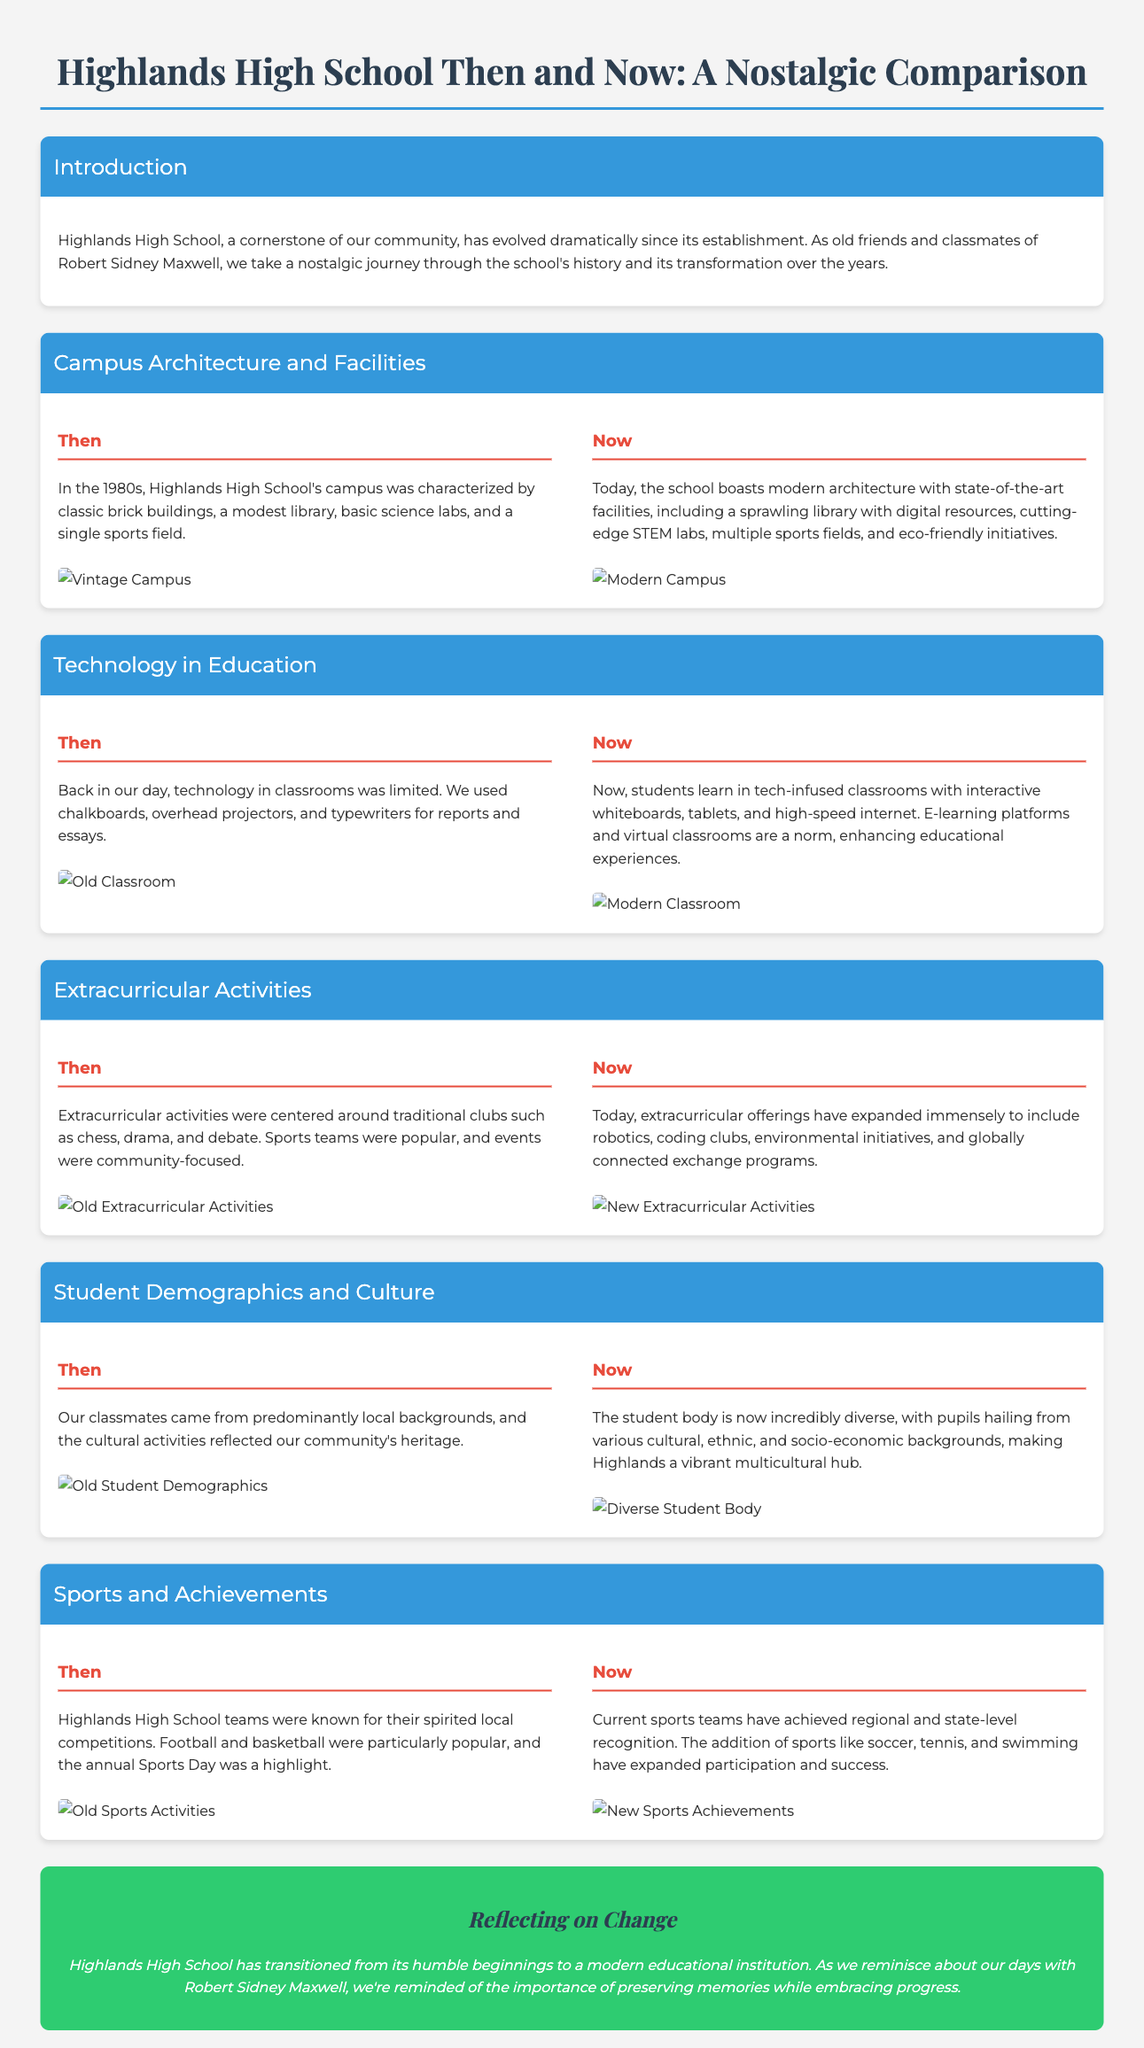What was the main focus of extracurricular activities in the past? The past extracurricular activities were centered around traditional clubs such as chess, drama, and debate.
Answer: Traditional clubs What modern technology is used in classrooms today? Classrooms today utilize interactive whiteboards, tablets, and high-speed internet.
Answer: Interactive whiteboards What significant architectural change has occurred at Highlands High School? The school now has state-of-the-art facilities, including a sprawling library with digital resources and cutting-edge STEM labs.
Answer: State-of-the-art facilities In which decade was Highlands High School's campus primarily characterized by classic brick buildings? The 1980s were characterized by classic brick buildings on the campus.
Answer: 1980s What is a notable new aspect of student demographics at Highlands High School now? The student body is now incredibly diverse.
Answer: Diverse What type of sports were particularly popular back in the day? Football and basketball were particularly popular.
Answer: Football and basketball What kind of initiatives does the current Highlands High School implement? Current initiatives include eco-friendly initiatives.
Answer: Eco-friendly initiatives What type of activities have expanded in today's extracurricular offerings? Today's extracurricular offerings include robotics, coding clubs, and environmental initiatives.
Answer: Robotics and coding clubs What does the conclusion emphasize about Highlands High School's transition? The conclusion emphasizes the importance of preserving memories while embracing progress.
Answer: Preserving memories 